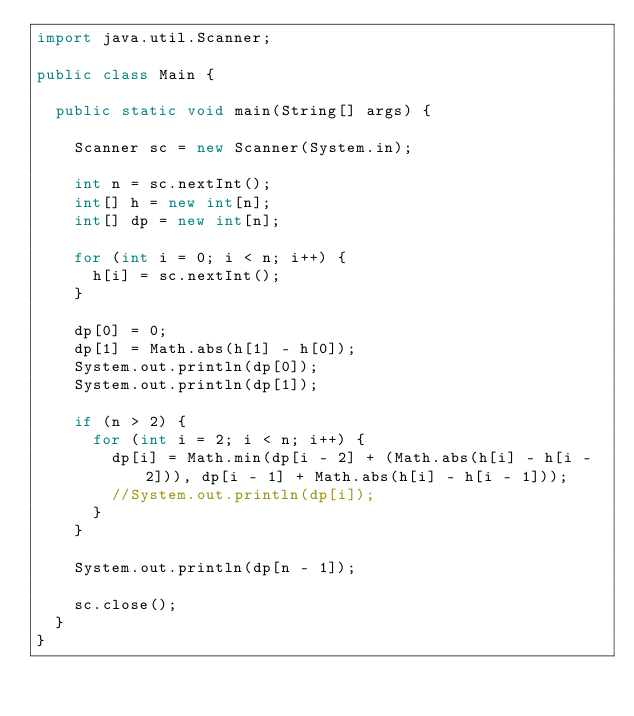Convert code to text. <code><loc_0><loc_0><loc_500><loc_500><_Java_>import java.util.Scanner;

public class Main {

	public static void main(String[] args) {

		Scanner sc = new Scanner(System.in);

		int n = sc.nextInt();
		int[] h = new int[n];
		int[] dp = new int[n];

		for (int i = 0; i < n; i++) {
			h[i] = sc.nextInt();
		}

		dp[0] = 0;
		dp[1] = Math.abs(h[1] - h[0]);
		System.out.println(dp[0]);
		System.out.println(dp[1]);

		if (n > 2) {
			for (int i = 2; i < n; i++) {
				dp[i] = Math.min(dp[i - 2] + (Math.abs(h[i] - h[i - 2])), dp[i - 1] + Math.abs(h[i] - h[i - 1]));
				//System.out.println(dp[i]);
			}
		}

		System.out.println(dp[n - 1]);

		sc.close();
	}
}</code> 